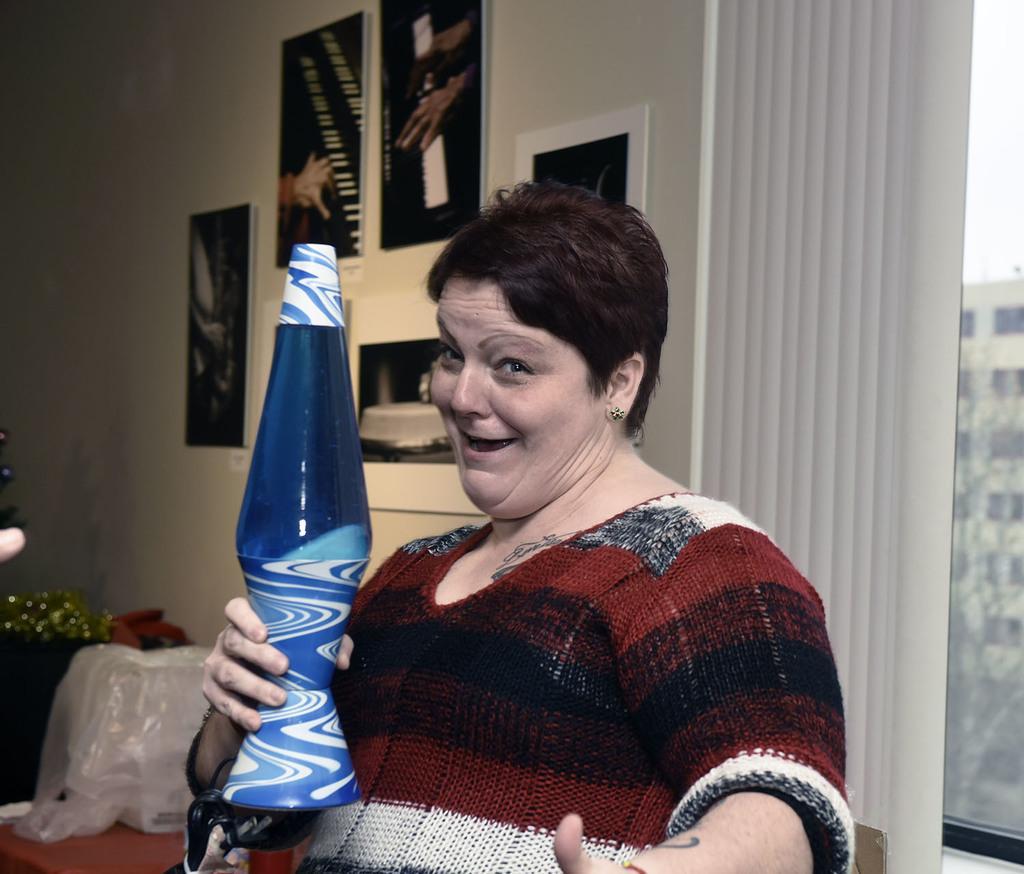How would you summarize this image in a sentence or two? In the picture I can see a woman holding a blue color object in her hand and there are few photo frames attached to the wall in the background and there are few other objects in the left corner. 